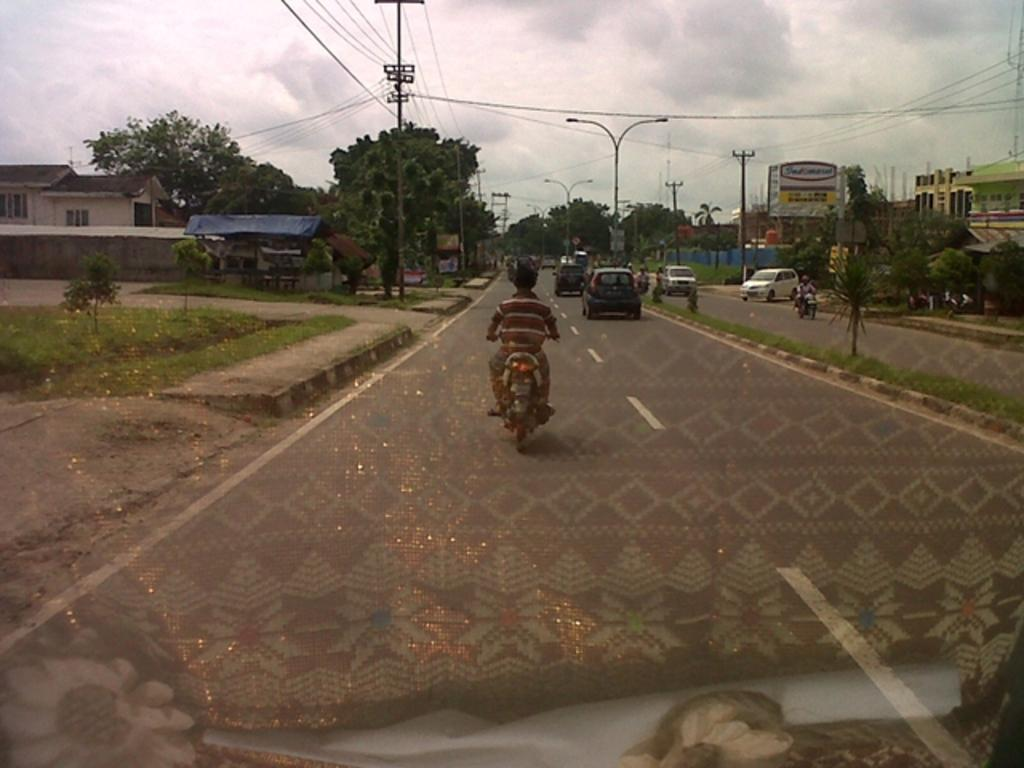What can be seen on the road in the image? There are vehicles on the road in the image. What type of vegetation is present in the image? There is grass, plants, and trees in the image. What structures can be seen in the image? There are poles and houses in the image. What else is present in the image besides the structures and vegetation? There are wires and hoardings in the image. What is visible in the background of the image? The sky is visible in the background of the image, with clouds present. Can you tell me how many eggs are being sold on the hoardings in the image? There are no eggs or references to eggs on the hoardings in the image. Is there an ocean visible in the background of the image? No, there is no ocean present in the image; only the sky with clouds is visible in the background. 